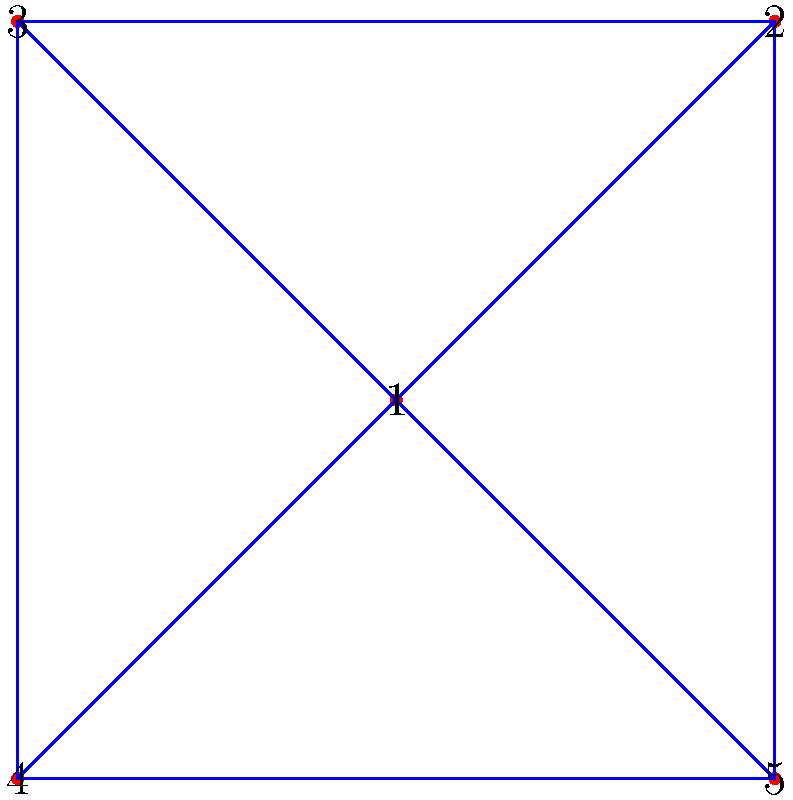Consider the graph shown above, which represents a simplified map where each vertex is a state and each edge represents adjacent states. What is the minimum number of colors needed to color this map so that no adjacent states have the same color? To determine the minimum number of colors needed, we can follow these steps:

1) First, we need to understand the concept of graph coloring. In this context, we want to assign colors to vertices (states) such that no two adjacent vertices have the same color.

2) The minimum number of colors required for such a coloring is called the chromatic number of the graph.

3) To find the chromatic number, we can use the following approach:

   a) Start with vertex 1. Assign it any color (let's say red).
   
   b) Move to vertex 2. It's adjacent to 1, so it needs a different color (say blue).
   
   c) Vertex 3 is adjacent to both 1 and 2, so it needs a third color (say green).
   
   d) Vertex 4 is adjacent to 1 and 3, but not 2. So we can color it blue.
   
   e) Vertex 5 is adjacent to 1 and 4, which are red and blue. We can color it green.

4) We've successfully colored the graph using 3 colors, and it's not possible to do it with fewer colors because vertices 1, 2, and 3 all need different colors.

5) Therefore, the chromatic number of this graph is 3.

This mirrors the real-world scenario of the Four Color Theorem, which states that any map can be colored with at most four colors, although many maps (like this simplified one) can be colored with fewer.
Answer: 3 colors 